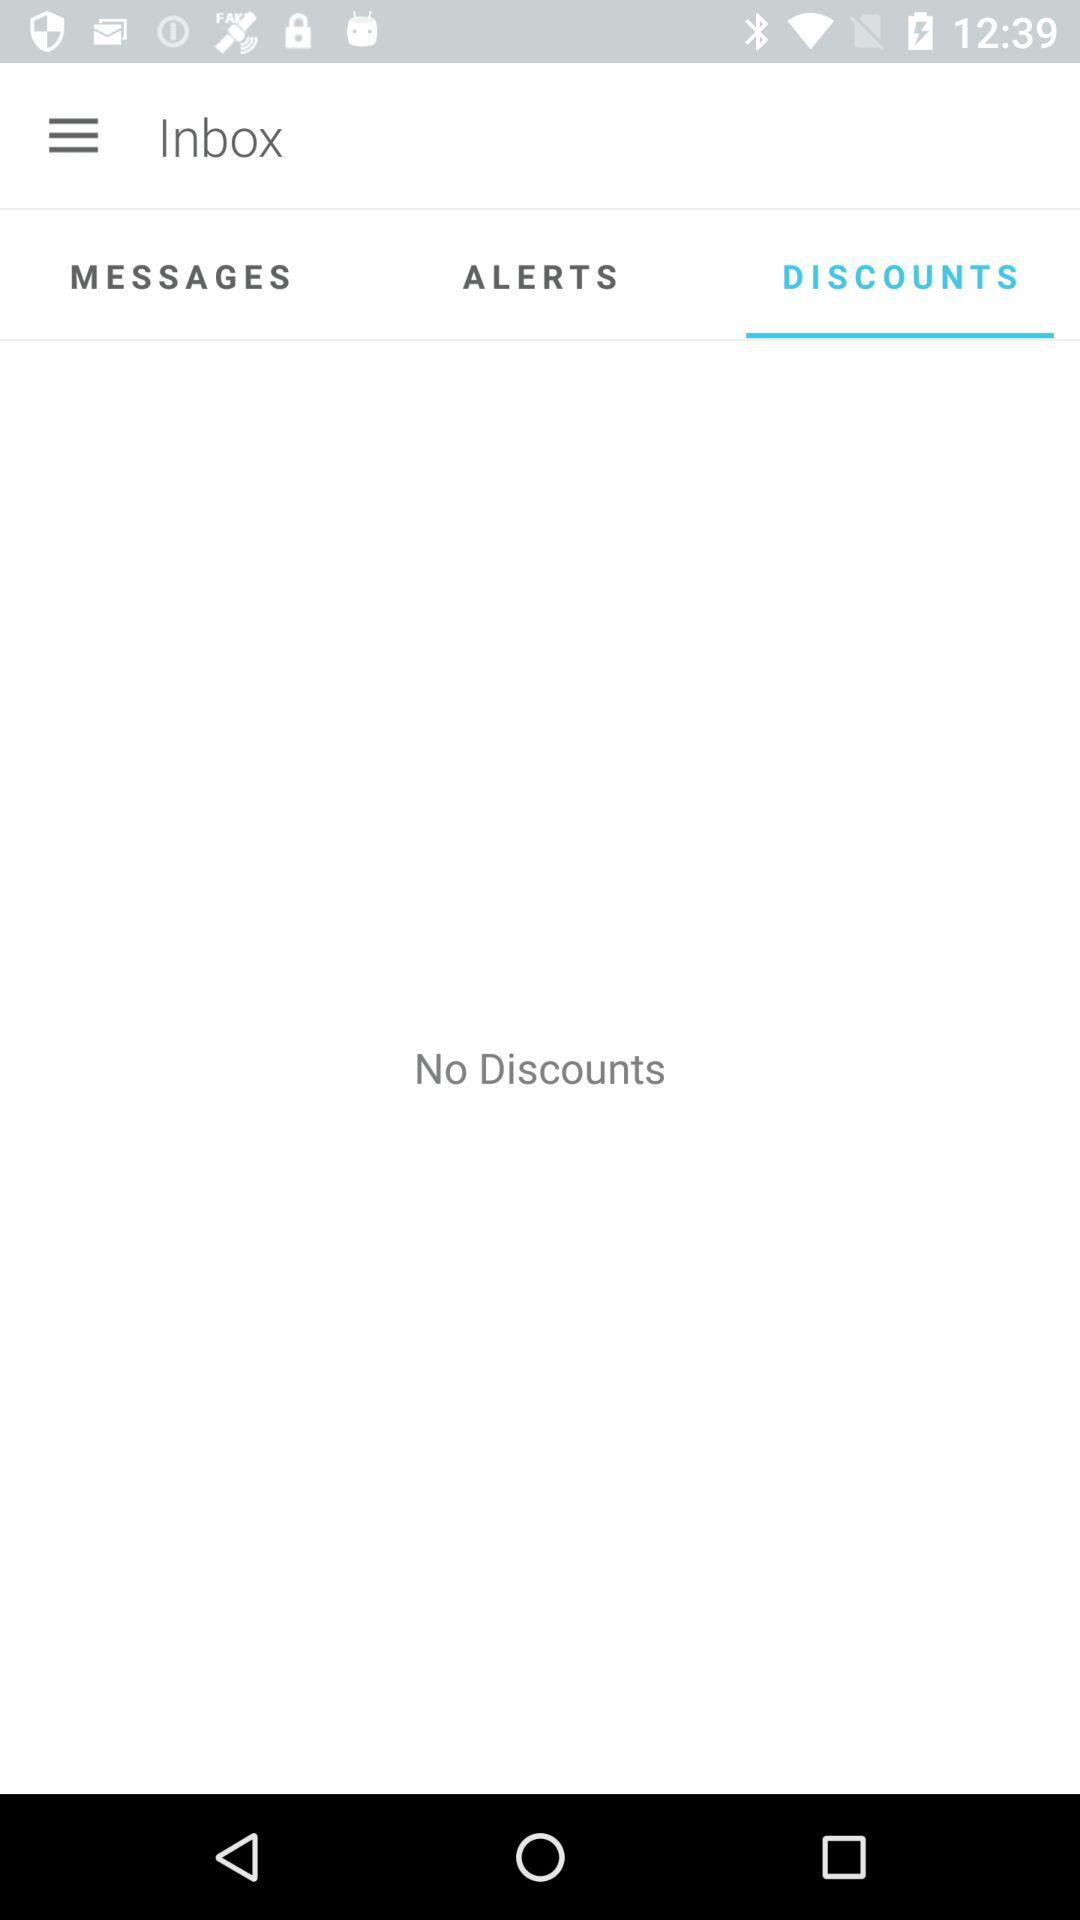Is there any discount? There is no discount. 